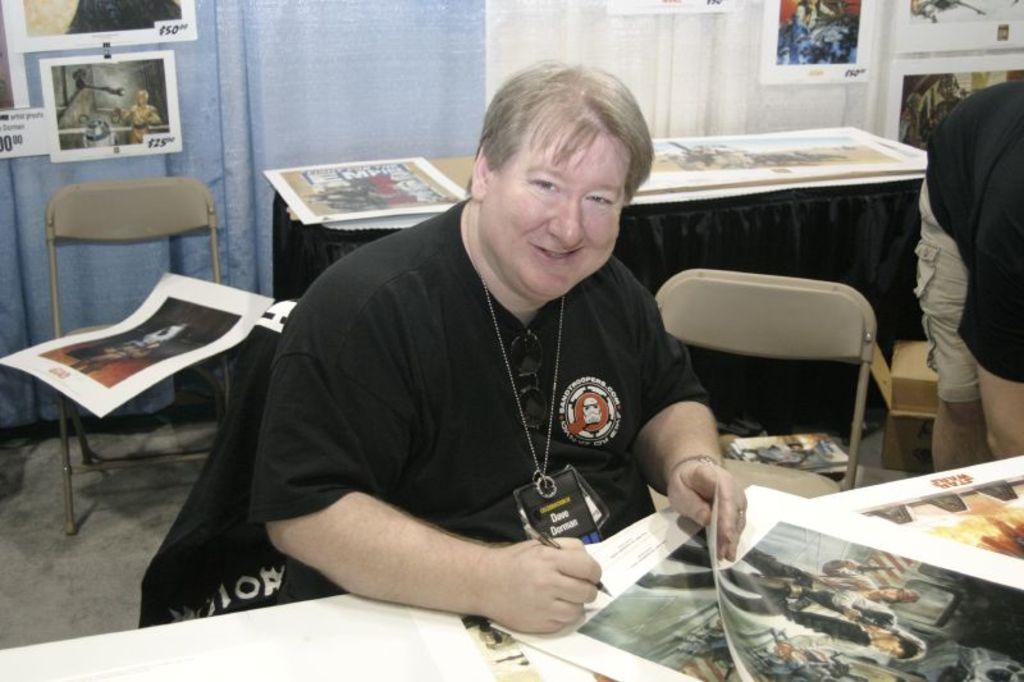How would you summarize this image in a sentence or two? In this picture we can see a man in white shirt sitting on the chair holding a pen in front of the table on which there is a paper and behind him there is a table and some charts. 